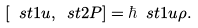<formula> <loc_0><loc_0><loc_500><loc_500>[ \ s t { 1 } { u } , \ s t { 2 } { P } ] = \hbar { \ } s t { 1 } { u } \rho .</formula> 